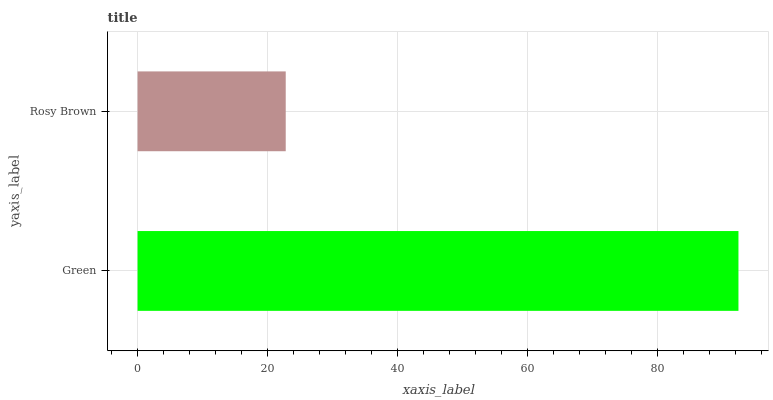Is Rosy Brown the minimum?
Answer yes or no. Yes. Is Green the maximum?
Answer yes or no. Yes. Is Rosy Brown the maximum?
Answer yes or no. No. Is Green greater than Rosy Brown?
Answer yes or no. Yes. Is Rosy Brown less than Green?
Answer yes or no. Yes. Is Rosy Brown greater than Green?
Answer yes or no. No. Is Green less than Rosy Brown?
Answer yes or no. No. Is Green the high median?
Answer yes or no. Yes. Is Rosy Brown the low median?
Answer yes or no. Yes. Is Rosy Brown the high median?
Answer yes or no. No. Is Green the low median?
Answer yes or no. No. 